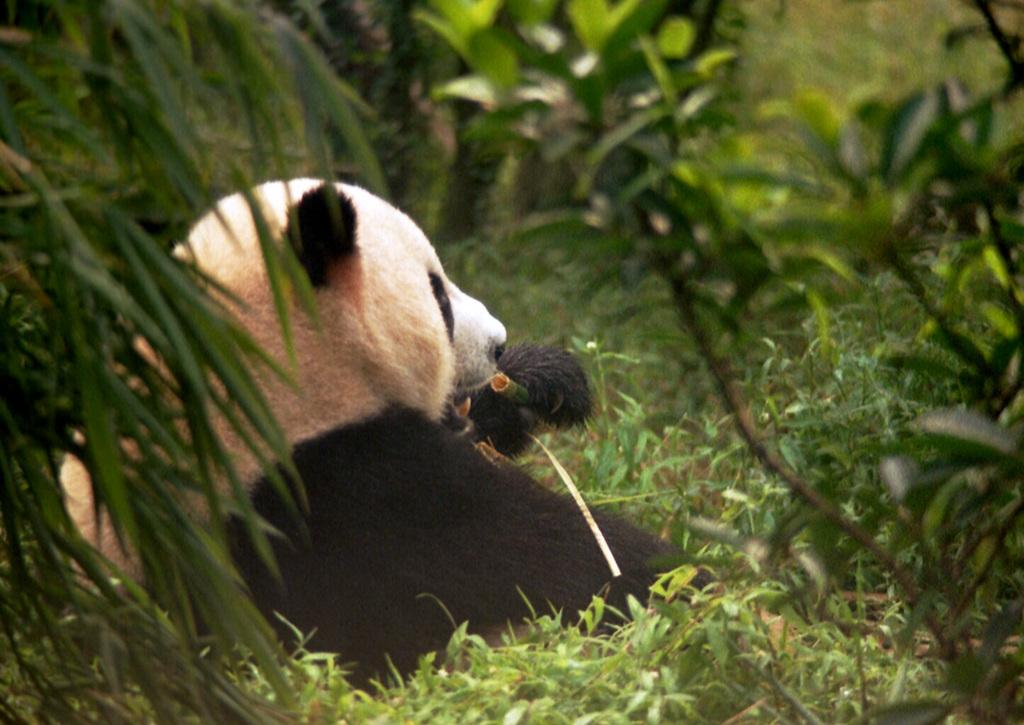What type of animal is in the image? There is a panda in the image. What other elements can be seen in the image besides the panda? There are plants in the image. What type of bone can be seen in the image? There is no bone present in the image. What type of honey is the panda eating in the image? There is no honey present in the image, and the panda is not shown eating anything. 